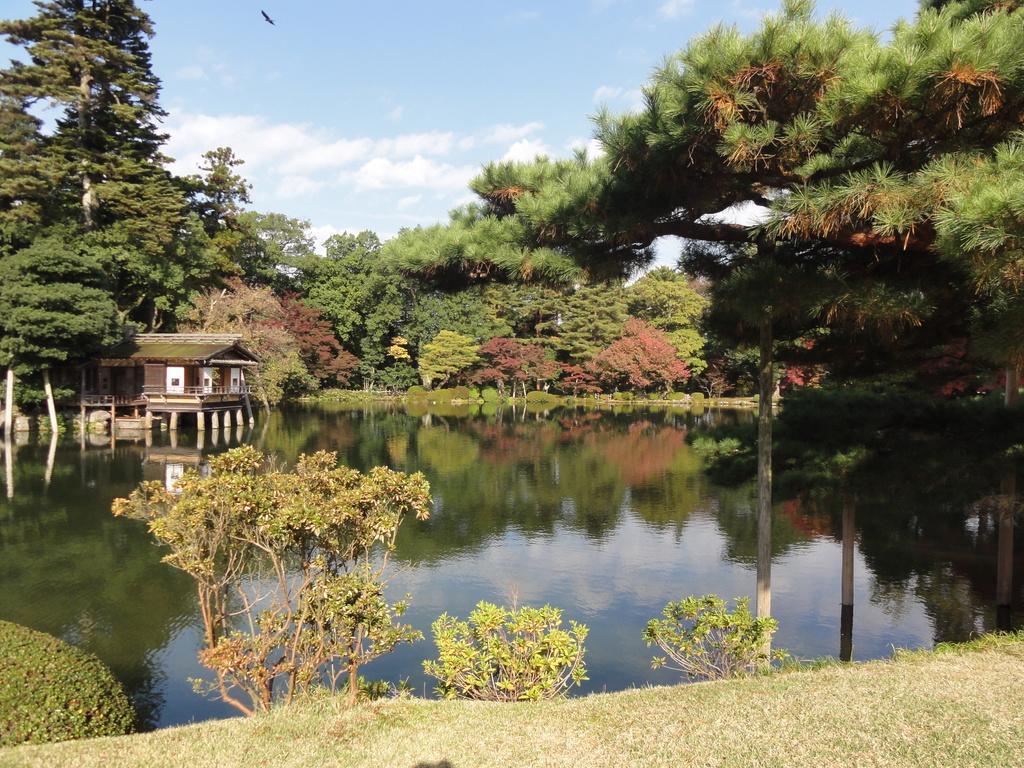Could you give a brief overview of what you see in this image? In the foreground we can see plants and grass. In the middle of the picture we can see water body. In the background there are trees, plants and house. At the top we can see sky and a bird. 